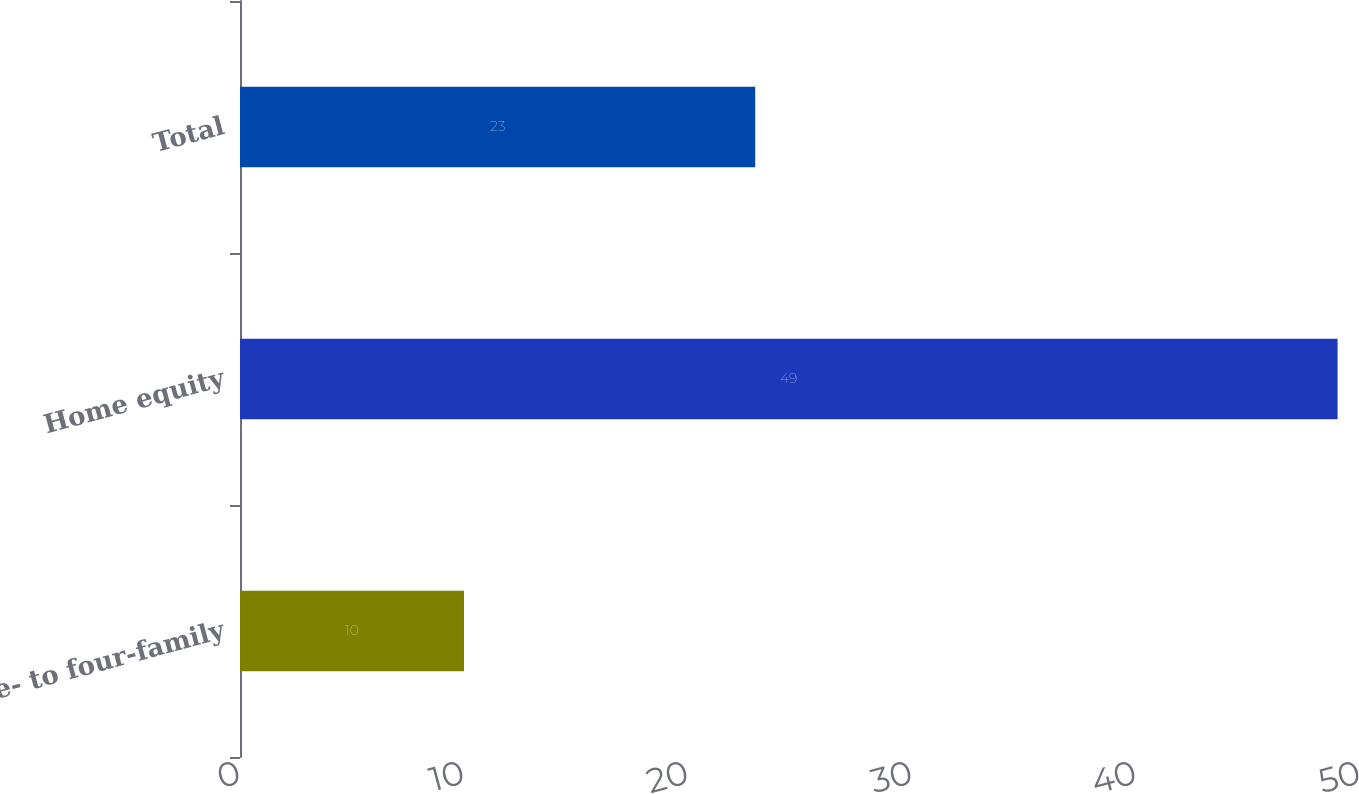Convert chart. <chart><loc_0><loc_0><loc_500><loc_500><bar_chart><fcel>One- to four-family<fcel>Home equity<fcel>Total<nl><fcel>10<fcel>49<fcel>23<nl></chart> 